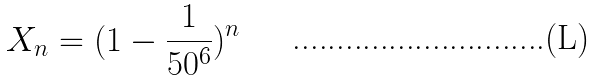<formula> <loc_0><loc_0><loc_500><loc_500>X _ { n } = ( 1 - \frac { 1 } { 5 0 ^ { 6 } } ) ^ { n }</formula> 